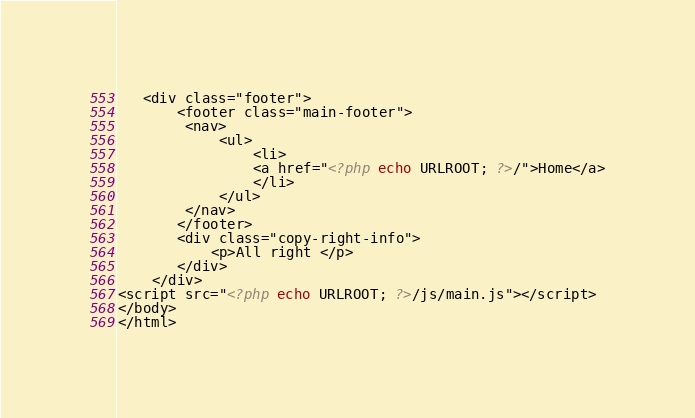Convert code to text. <code><loc_0><loc_0><loc_500><loc_500><_PHP_>
   <div class="footer">
       <footer class="main-footer">
        <nav>
            <ul>
                <li>
                <a href="<?php echo URLROOT; ?>/">Home</a>
                </li>
            </ul>
        </nav>
       </footer>
       <div class="copy-right-info">
           <p>All right </p>
       </div>
    </div>
<script src="<?php echo URLROOT; ?>/js/main.js"></script>
</body>
</html></code> 